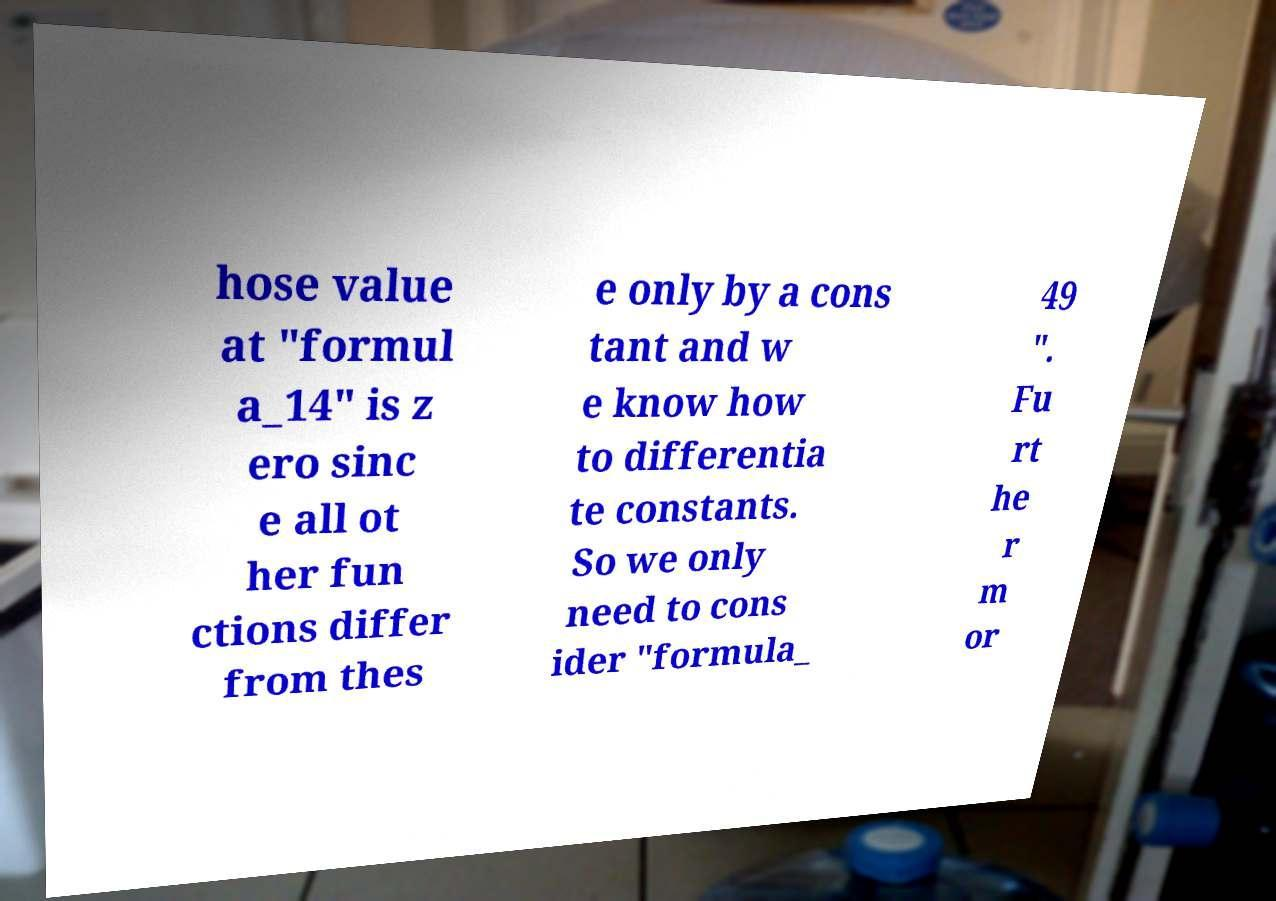For documentation purposes, I need the text within this image transcribed. Could you provide that? hose value at "formul a_14" is z ero sinc e all ot her fun ctions differ from thes e only by a cons tant and w e know how to differentia te constants. So we only need to cons ider "formula_ 49 ". Fu rt he r m or 